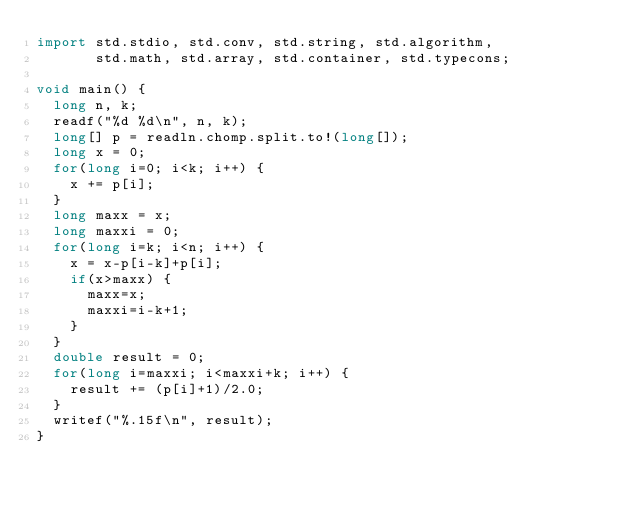<code> <loc_0><loc_0><loc_500><loc_500><_D_>import std.stdio, std.conv, std.string, std.algorithm,
       std.math, std.array, std.container, std.typecons;

void main() {
  long n, k;
  readf("%d %d\n", n, k);
  long[] p = readln.chomp.split.to!(long[]);
  long x = 0;
  for(long i=0; i<k; i++) {
    x += p[i];
  }
  long maxx = x;
  long maxxi = 0;
  for(long i=k; i<n; i++) {
    x = x-p[i-k]+p[i];
    if(x>maxx) {
      maxx=x;
      maxxi=i-k+1;
    }
  }
  double result = 0;
  for(long i=maxxi; i<maxxi+k; i++) {
    result += (p[i]+1)/2.0;
  }
  writef("%.15f\n", result);
}

</code> 